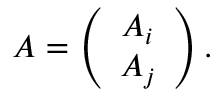Convert formula to latex. <formula><loc_0><loc_0><loc_500><loc_500>A = \left ( \begin{array} { c } { { A _ { i } } } \\ { { A _ { j } } } \end{array} \right ) .</formula> 